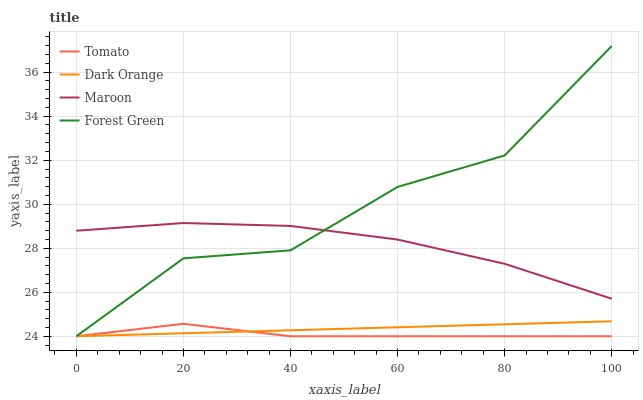Does Tomato have the minimum area under the curve?
Answer yes or no. Yes. Does Forest Green have the maximum area under the curve?
Answer yes or no. Yes. Does Dark Orange have the minimum area under the curve?
Answer yes or no. No. Does Dark Orange have the maximum area under the curve?
Answer yes or no. No. Is Dark Orange the smoothest?
Answer yes or no. Yes. Is Forest Green the roughest?
Answer yes or no. Yes. Is Forest Green the smoothest?
Answer yes or no. No. Is Dark Orange the roughest?
Answer yes or no. No. Does Tomato have the lowest value?
Answer yes or no. Yes. Does Maroon have the lowest value?
Answer yes or no. No. Does Forest Green have the highest value?
Answer yes or no. Yes. Does Dark Orange have the highest value?
Answer yes or no. No. Is Tomato less than Maroon?
Answer yes or no. Yes. Is Maroon greater than Tomato?
Answer yes or no. Yes. Does Tomato intersect Dark Orange?
Answer yes or no. Yes. Is Tomato less than Dark Orange?
Answer yes or no. No. Is Tomato greater than Dark Orange?
Answer yes or no. No. Does Tomato intersect Maroon?
Answer yes or no. No. 